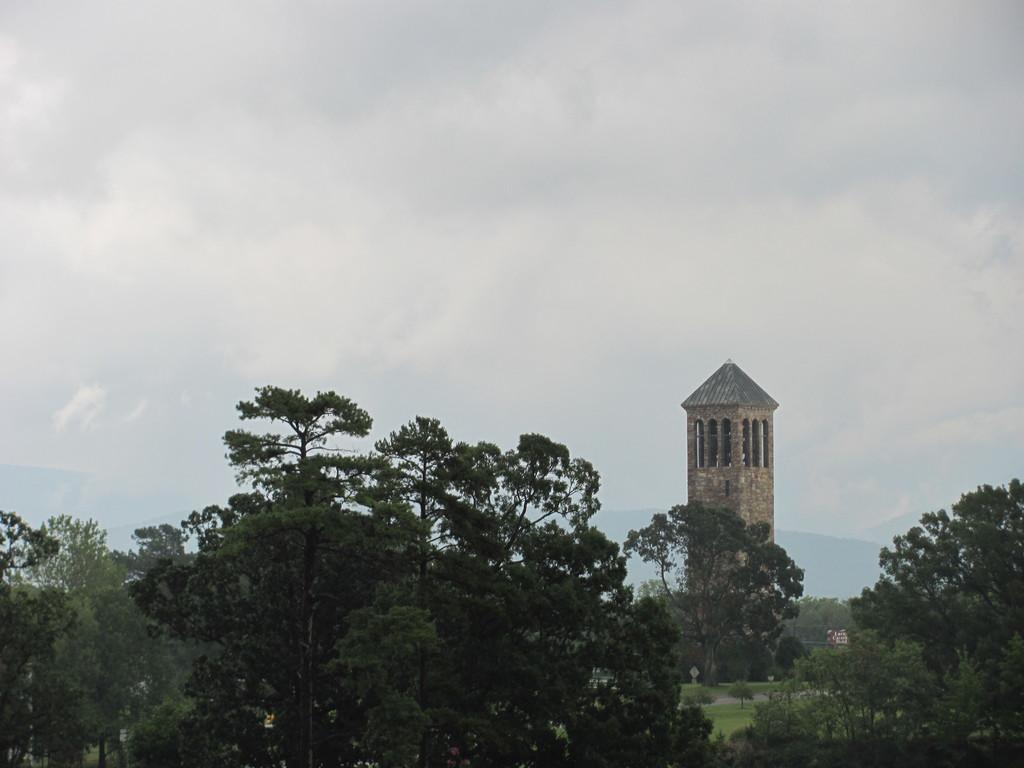What type of vegetation is on the down side of the image? There are trees on the down side of the image. What can be seen on the right side of the image? There is a structure on the right side of the image. What is the condition of the sky in the image? The sky is cloudy at the top of the image. What page is the manager reading in the image? There is no page or manager present in the image. How many cents are visible on the down side of the image? There are no cents present in the image. 